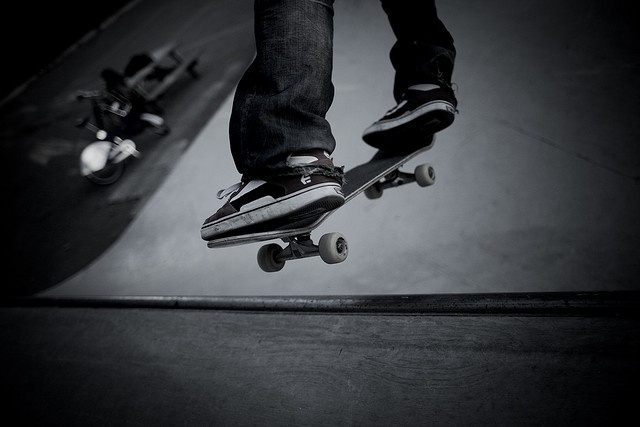Describe the objects in this image and their specific colors. I can see people in black, gray, and darkgray tones, bicycle in black, gray, darkgray, and lightgray tones, and skateboard in black, gray, and darkgray tones in this image. 